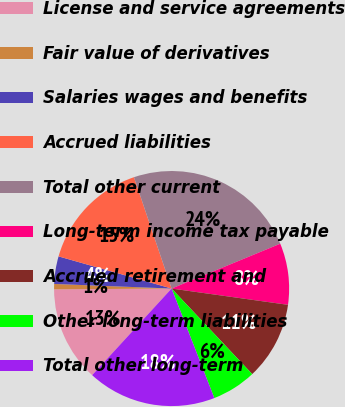Convert chart. <chart><loc_0><loc_0><loc_500><loc_500><pie_chart><fcel>License and service agreements<fcel>Fair value of derivatives<fcel>Salaries wages and benefits<fcel>Accrued liabilities<fcel>Total other current<fcel>Long-term income tax payable<fcel>Accrued retirement and<fcel>Other long-term liabilities<fcel>Total other long-term<nl><fcel>13.08%<fcel>0.73%<fcel>3.79%<fcel>15.4%<fcel>23.96%<fcel>8.44%<fcel>10.76%<fcel>6.11%<fcel>17.73%<nl></chart> 